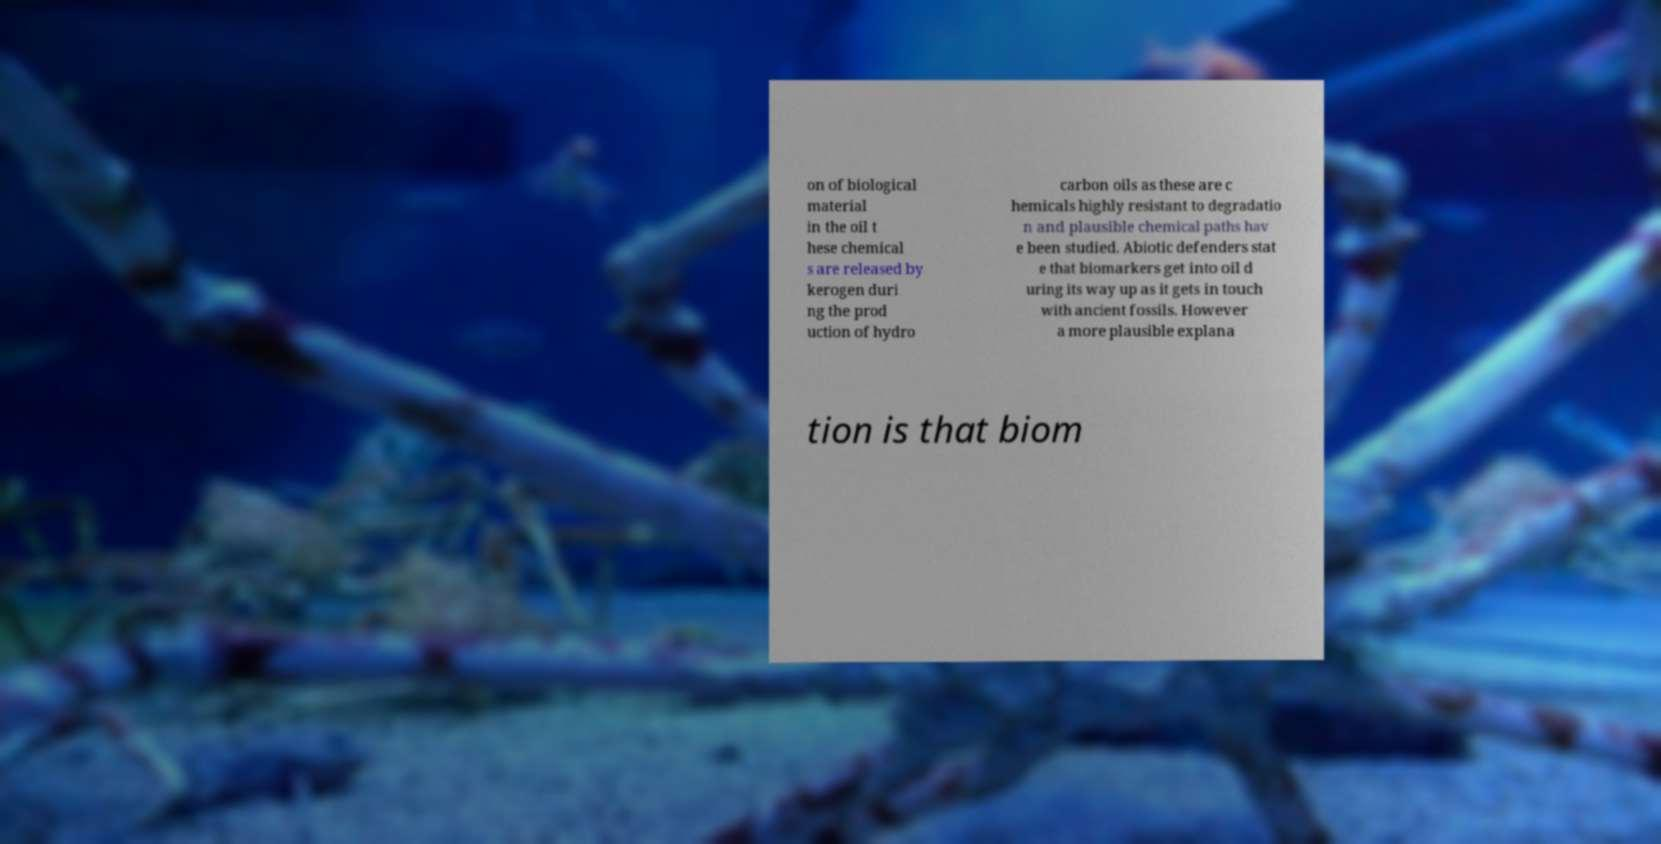Can you read and provide the text displayed in the image?This photo seems to have some interesting text. Can you extract and type it out for me? on of biological material in the oil t hese chemical s are released by kerogen duri ng the prod uction of hydro carbon oils as these are c hemicals highly resistant to degradatio n and plausible chemical paths hav e been studied. Abiotic defenders stat e that biomarkers get into oil d uring its way up as it gets in touch with ancient fossils. However a more plausible explana tion is that biom 